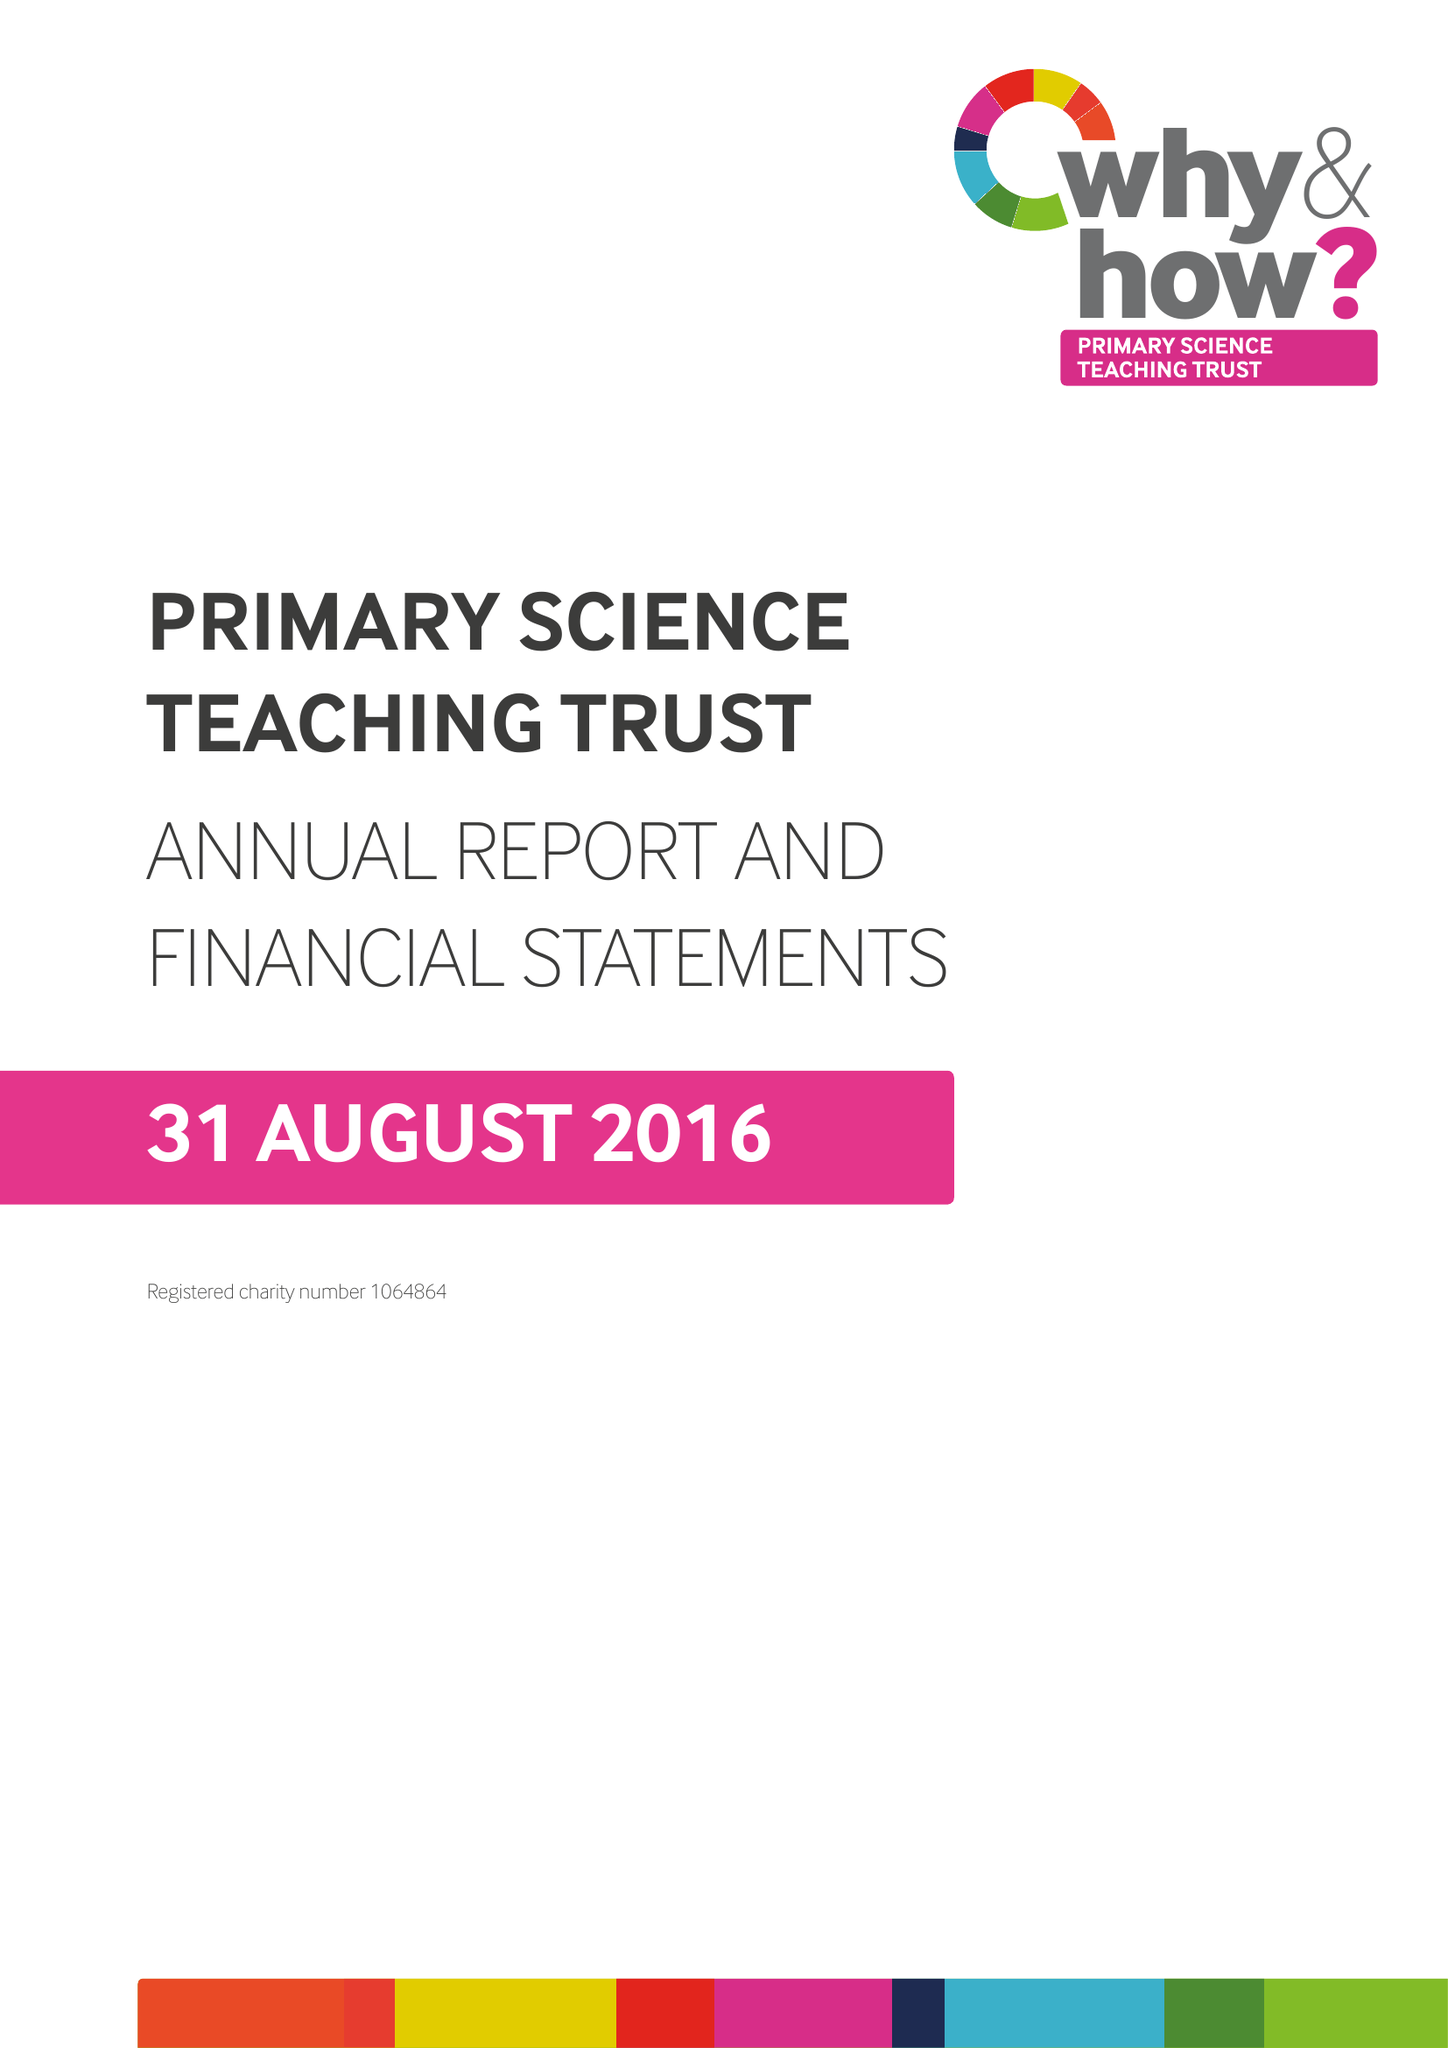What is the value for the address__post_town?
Answer the question using a single word or phrase. BRISTOL 